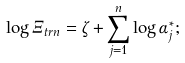<formula> <loc_0><loc_0><loc_500><loc_500>\log \Xi _ { t r n } = \zeta + \sum _ { j = 1 } ^ { n } \log \alpha _ { j } ^ { \ast } ;</formula> 